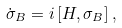<formula> <loc_0><loc_0><loc_500><loc_500>\dot { \sigma } _ { B } = i \left [ H , \sigma _ { B } \right ] ,</formula> 